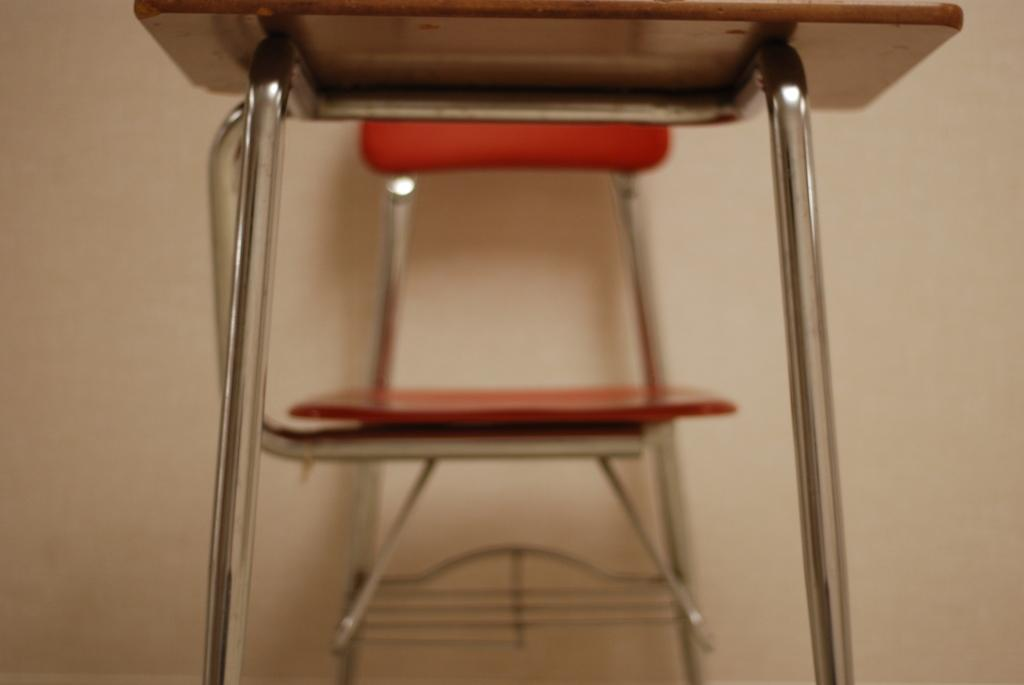Where was the image taken? The image was taken inside a room. What is located in the middle of the image? There is a table and a chair in the middle of the image. What can be seen in the background of the image? There is a wall visible in the background of the image. What type of frame is visible around the edge of the image? There is no frame visible around the edge of the image, as it is not a physical object but a digital representation. 